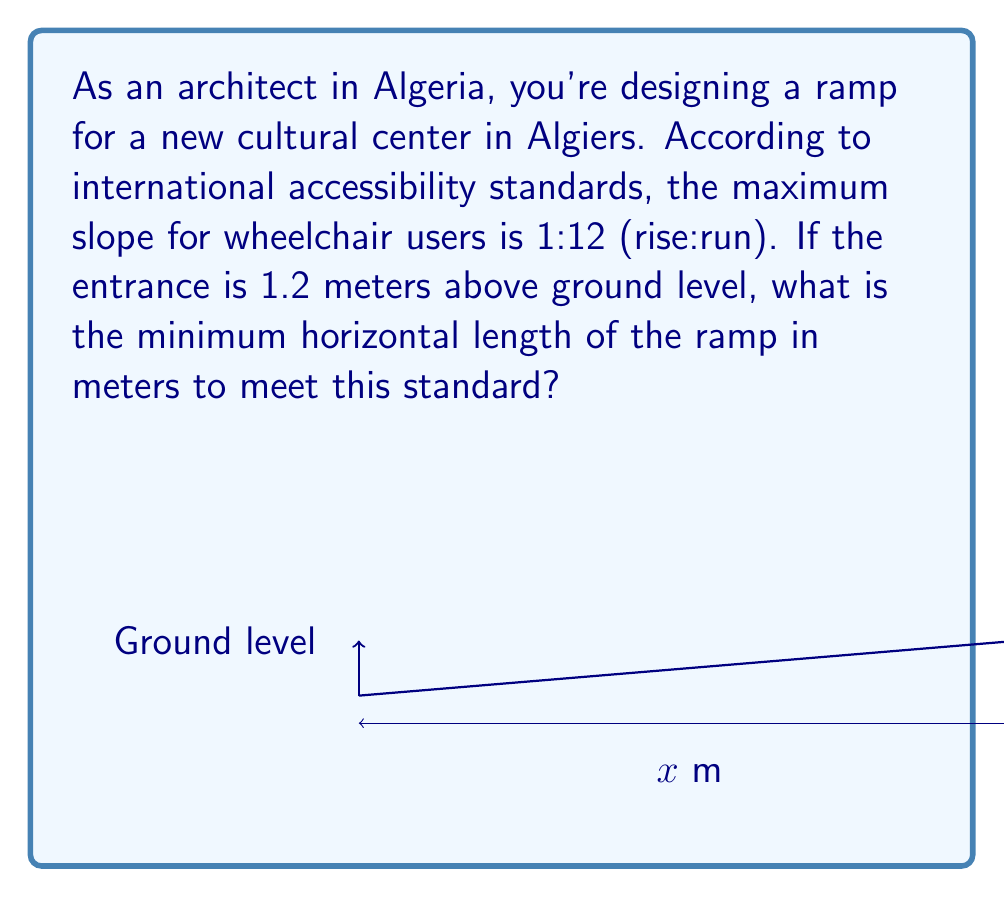Help me with this question. Let's approach this step-by-step:

1) The slope standard of 1:12 means for every 1 unit of rise, there must be 12 units of run.

2) We can express this as a ratio: $\frac{\text{rise}}{\text{run}} = \frac{1}{12}$

3) In our case, the rise is 1.2 meters. Let's call the unknown run $x$ meters.

4) We can set up the equation:

   $\frac{1.2}{x} = \frac{1}{12}$

5) To solve for $x$, we can cross-multiply:

   $1.2 \cdot 12 = 1 \cdot x$

6) Simplify:

   $14.4 = x$

7) Therefore, the minimum horizontal length of the ramp should be 14.4 meters.

This ensures that the slope doesn't exceed the 1:12 ratio, making it accessible for wheelchair users according to international standards.
Answer: 14.4 meters 